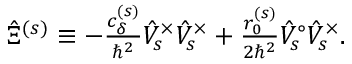<formula> <loc_0><loc_0><loc_500><loc_500>\begin{array} { r } { \hat { \Xi } ^ { ( s ) } \equiv - \frac { c _ { \delta } ^ { ( s ) } } { \hbar { ^ } { 2 } } \hat { V } _ { s } ^ { \times } \hat { V } _ { s } ^ { \times } + \frac { r _ { 0 } ^ { ( s ) } } { 2 \hbar { ^ } { 2 } } \hat { V } _ { s } ^ { \circ } \hat { V } _ { s } ^ { \times } . } \end{array}</formula> 